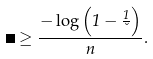Convert formula to latex. <formula><loc_0><loc_0><loc_500><loc_500>\Delta \geq \frac { - \log \left ( 1 - \frac { 1 } { \lambda } \right ) } { n } .</formula> 